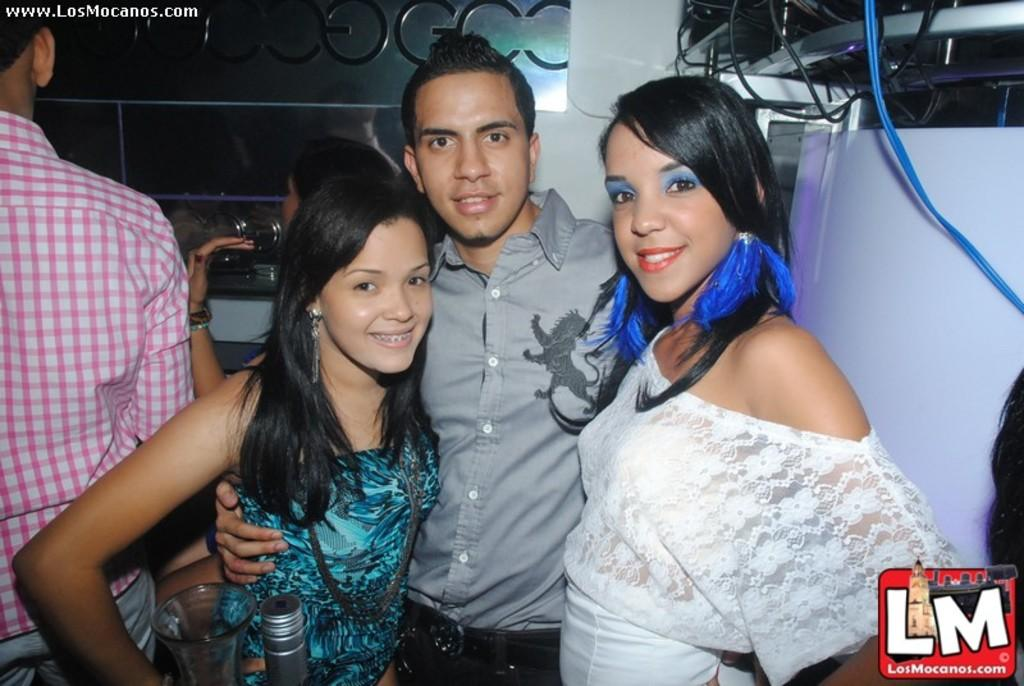What can be seen in the image involving people? There are people standing in the image. What objects are present in the image related to beverages? There is a bottle and a glass in the image. How are the people in the image feeling or expressing themselves? The people in the image have smiles on their faces, indicating happiness or enjoyment. What type of barrier can be seen in the image? There is a metal fence in the image. How many people are sleeping in the image? There are no people sleeping in the image; all the people have smiles on their faces. What type of sticks are being used by the people in the image? There are no sticks present in the image; the people are standing near a metal fence. 